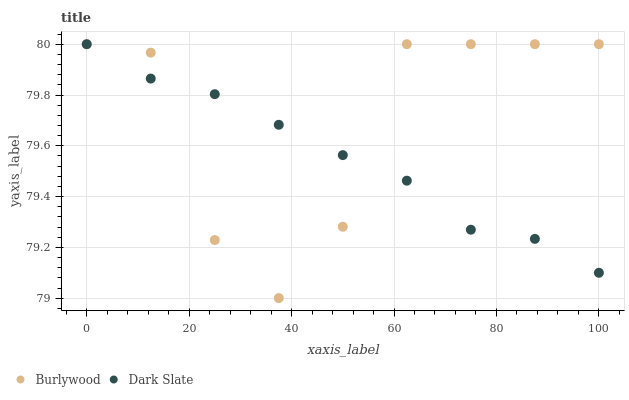Does Dark Slate have the minimum area under the curve?
Answer yes or no. Yes. Does Burlywood have the maximum area under the curve?
Answer yes or no. Yes. Does Dark Slate have the maximum area under the curve?
Answer yes or no. No. Is Dark Slate the smoothest?
Answer yes or no. Yes. Is Burlywood the roughest?
Answer yes or no. Yes. Is Dark Slate the roughest?
Answer yes or no. No. Does Burlywood have the lowest value?
Answer yes or no. Yes. Does Dark Slate have the lowest value?
Answer yes or no. No. Does Dark Slate have the highest value?
Answer yes or no. Yes. Does Dark Slate intersect Burlywood?
Answer yes or no. Yes. Is Dark Slate less than Burlywood?
Answer yes or no. No. Is Dark Slate greater than Burlywood?
Answer yes or no. No. 